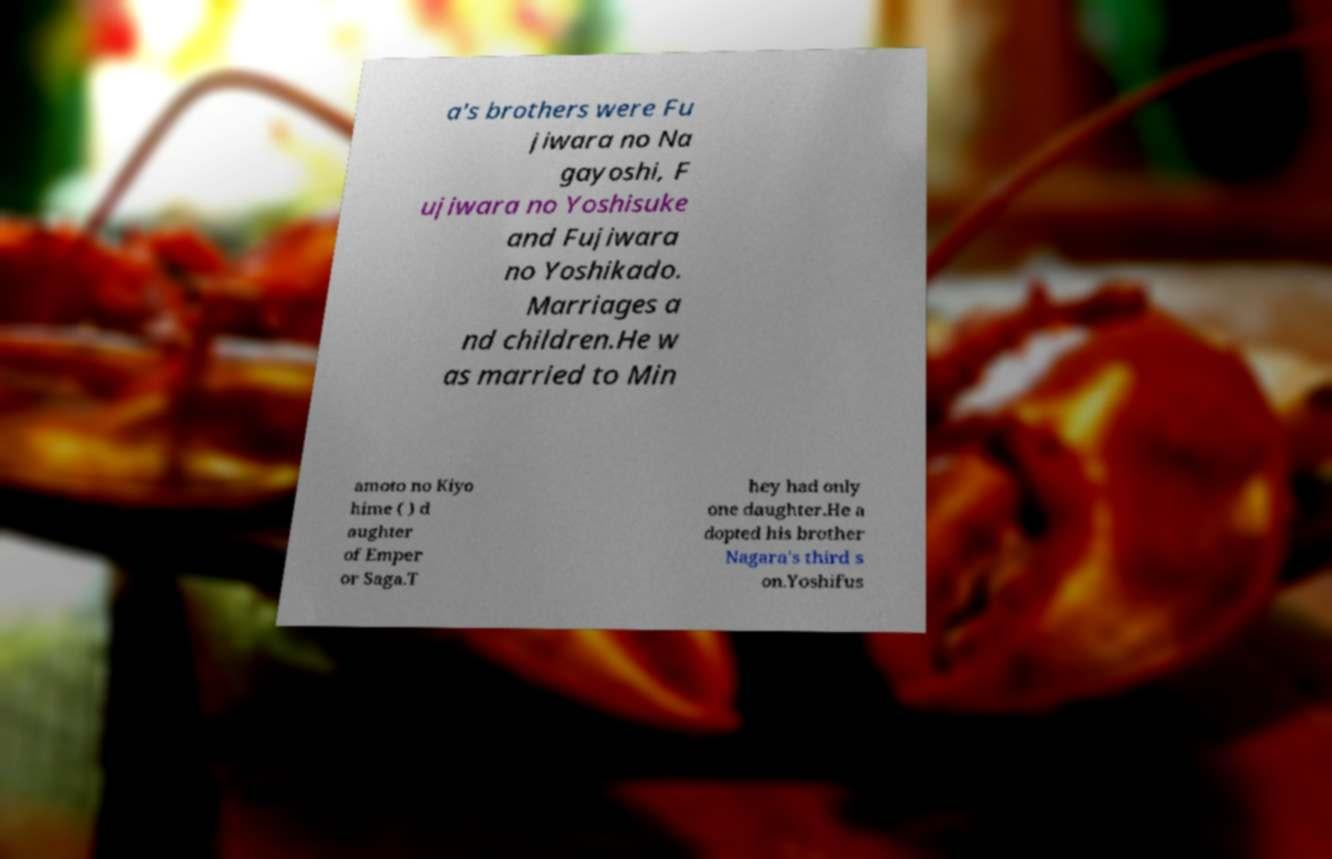I need the written content from this picture converted into text. Can you do that? a's brothers were Fu jiwara no Na gayoshi, F ujiwara no Yoshisuke and Fujiwara no Yoshikado. Marriages a nd children.He w as married to Min amoto no Kiyo hime ( ) d aughter of Emper or Saga.T hey had only one daughter.He a dopted his brother Nagara's third s on.Yoshifus 